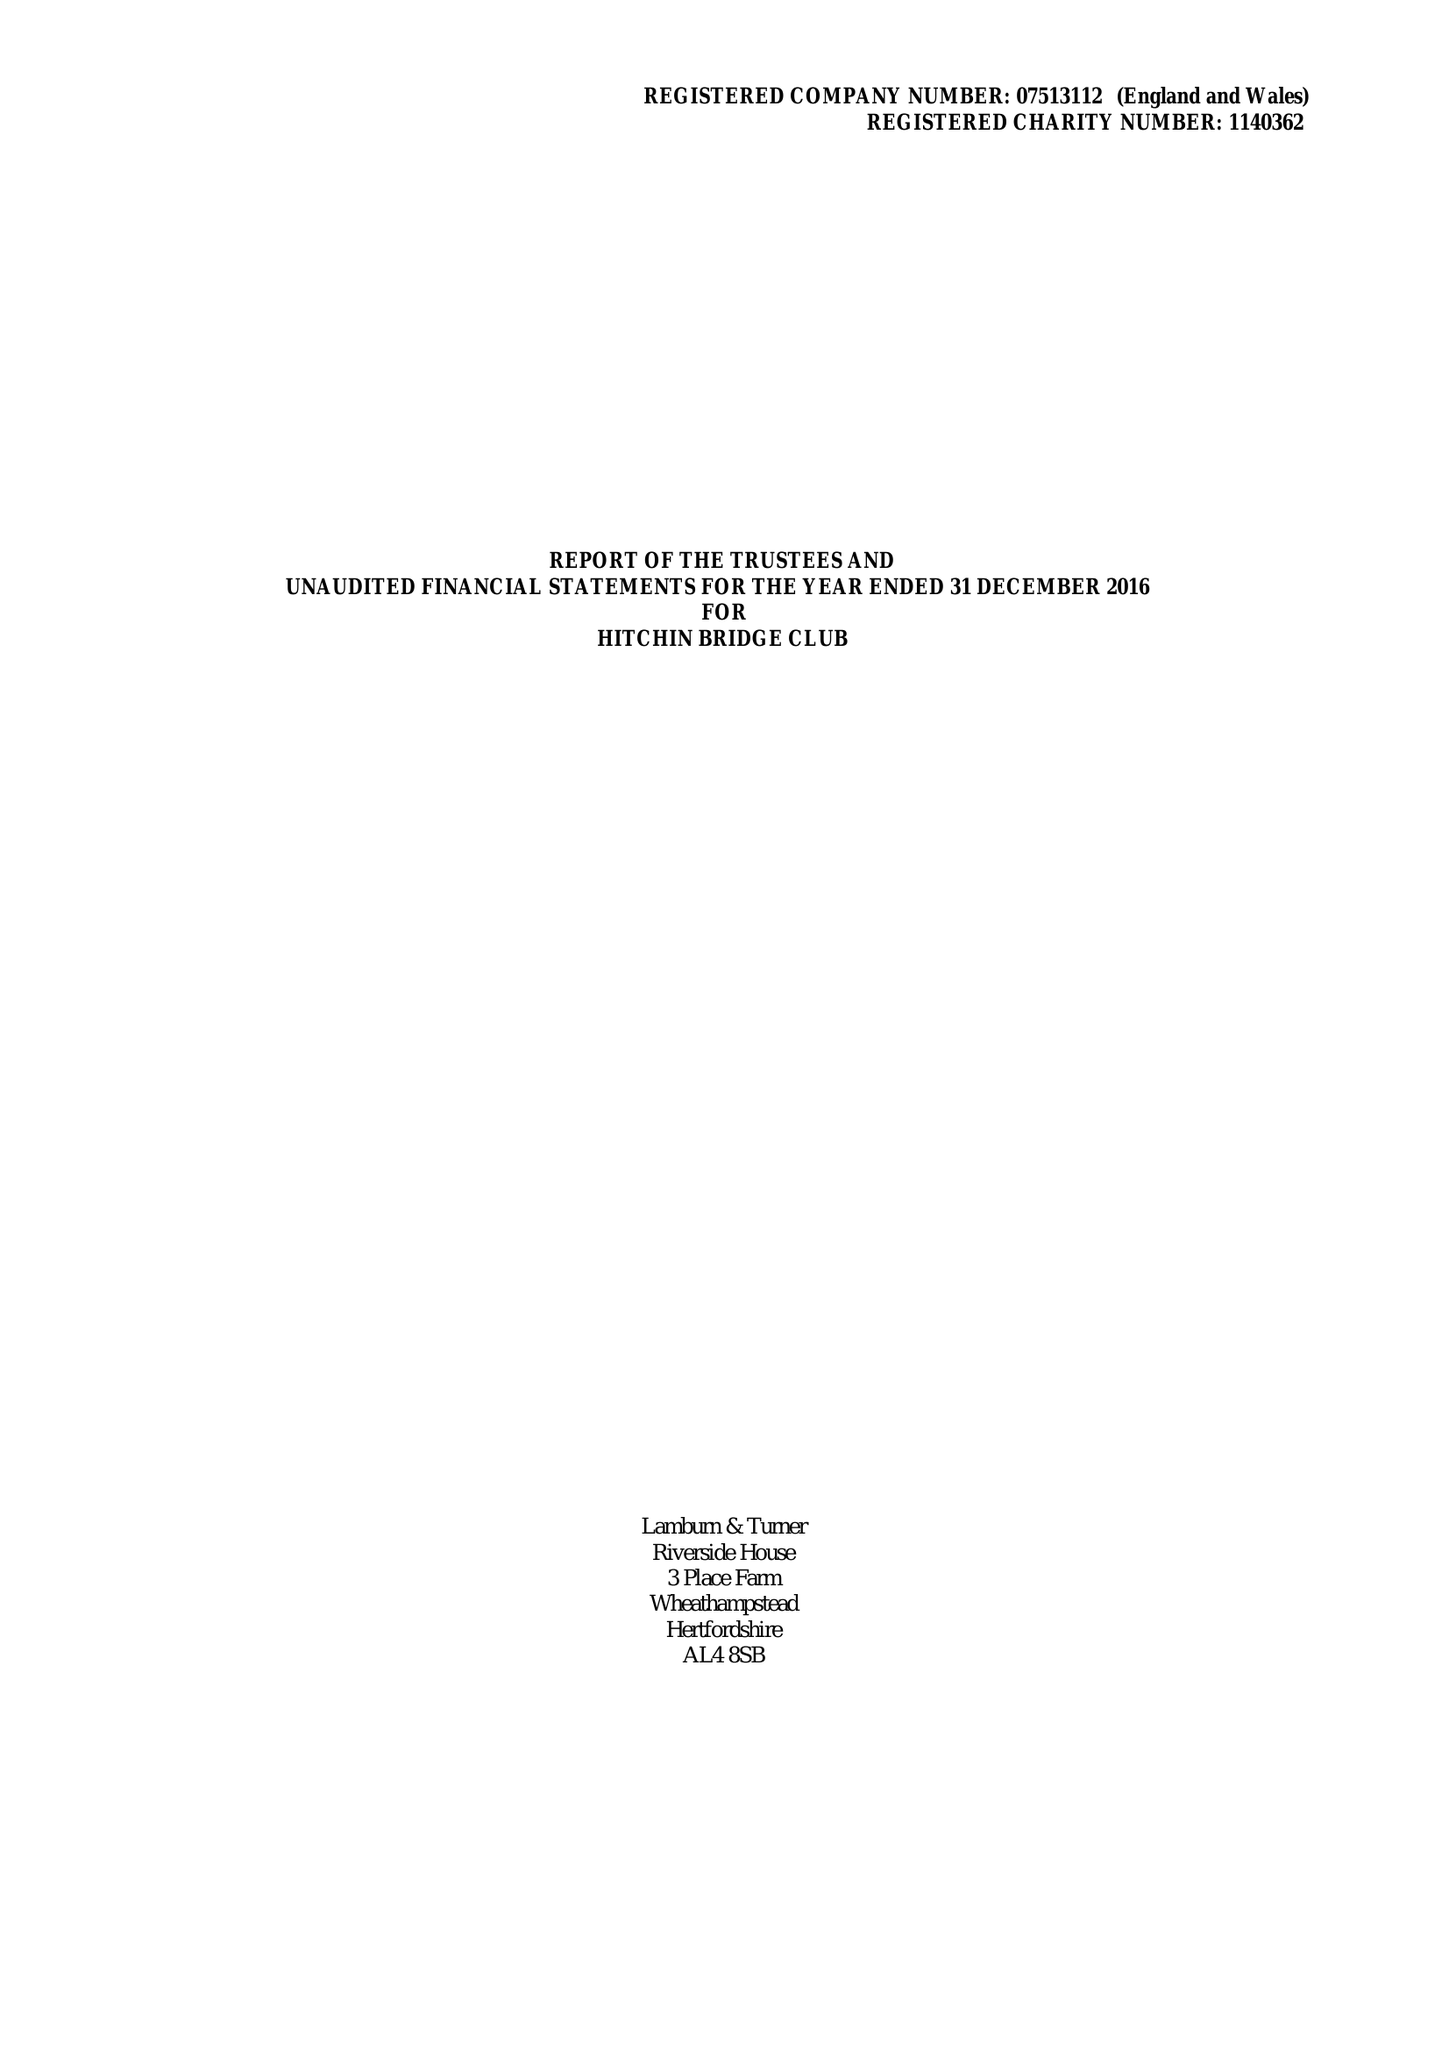What is the value for the charity_number?
Answer the question using a single word or phrase. 1140362 